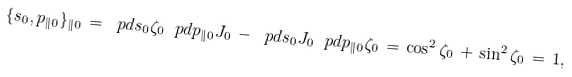Convert formula to latex. <formula><loc_0><loc_0><loc_500><loc_500>\{ s _ { 0 } , p _ { \| 0 } \} _ { \| 0 } \, = \, \ p d { s _ { 0 } } { \zeta _ { 0 } } \, \ p d { p _ { \| 0 } } { J _ { 0 } } \, - \, \ p d { s _ { 0 } } { J _ { 0 } } \, \ p d { p _ { \| 0 } } { \zeta _ { 0 } } \, = \, \cos ^ { 2 } \zeta _ { 0 } \, + \, \sin ^ { 2 } \zeta _ { 0 } \, = \, 1 ,</formula> 